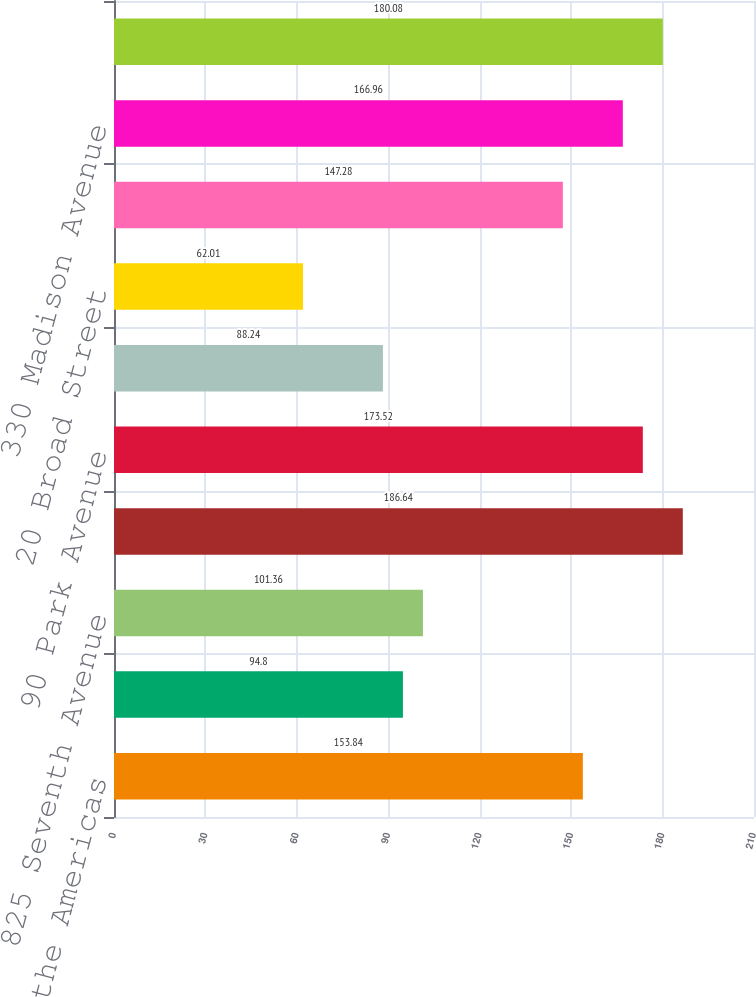Convert chart. <chart><loc_0><loc_0><loc_500><loc_500><bar_chart><fcel>1290 Avenue of the Americas<fcel>One Penn Plaza<fcel>825 Seventh Avenue<fcel>888 Seventh Avenue<fcel>90 Park Avenue<fcel>Two Penn Plaza<fcel>20 Broad Street<fcel>770 Broadway<fcel>330 Madison Avenue<fcel>909 Third Avenue<nl><fcel>153.84<fcel>94.8<fcel>101.36<fcel>186.64<fcel>173.52<fcel>88.24<fcel>62.01<fcel>147.28<fcel>166.96<fcel>180.08<nl></chart> 